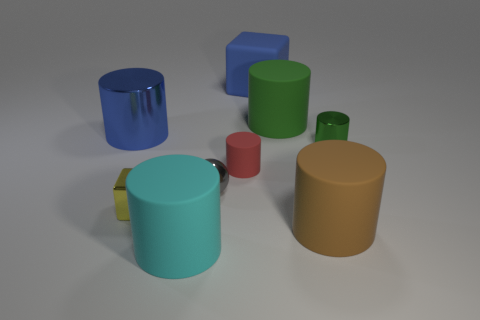What number of green matte objects have the same shape as the small red rubber thing?
Ensure brevity in your answer.  1. What number of balls are either green things or big cyan rubber objects?
Your answer should be compact. 0. Do the object that is to the right of the large brown object and the blue thing on the left side of the small yellow metallic block have the same shape?
Your answer should be very brief. Yes. What is the tiny yellow thing made of?
Your response must be concise. Metal. What shape is the rubber object that is the same color as the big metallic thing?
Provide a short and direct response. Cube. How many other cyan matte cylinders have the same size as the cyan cylinder?
Your answer should be compact. 0. How many things are either cubes behind the tiny gray metallic object or big metallic things that are on the left side of the big cyan rubber cylinder?
Your response must be concise. 2. Does the large cylinder to the left of the cyan rubber object have the same material as the small thing to the left of the cyan cylinder?
Keep it short and to the point. Yes. The metal thing that is on the right side of the green object left of the green shiny cylinder is what shape?
Your answer should be compact. Cylinder. Is there any other thing of the same color as the big metal object?
Offer a very short reply. Yes. 